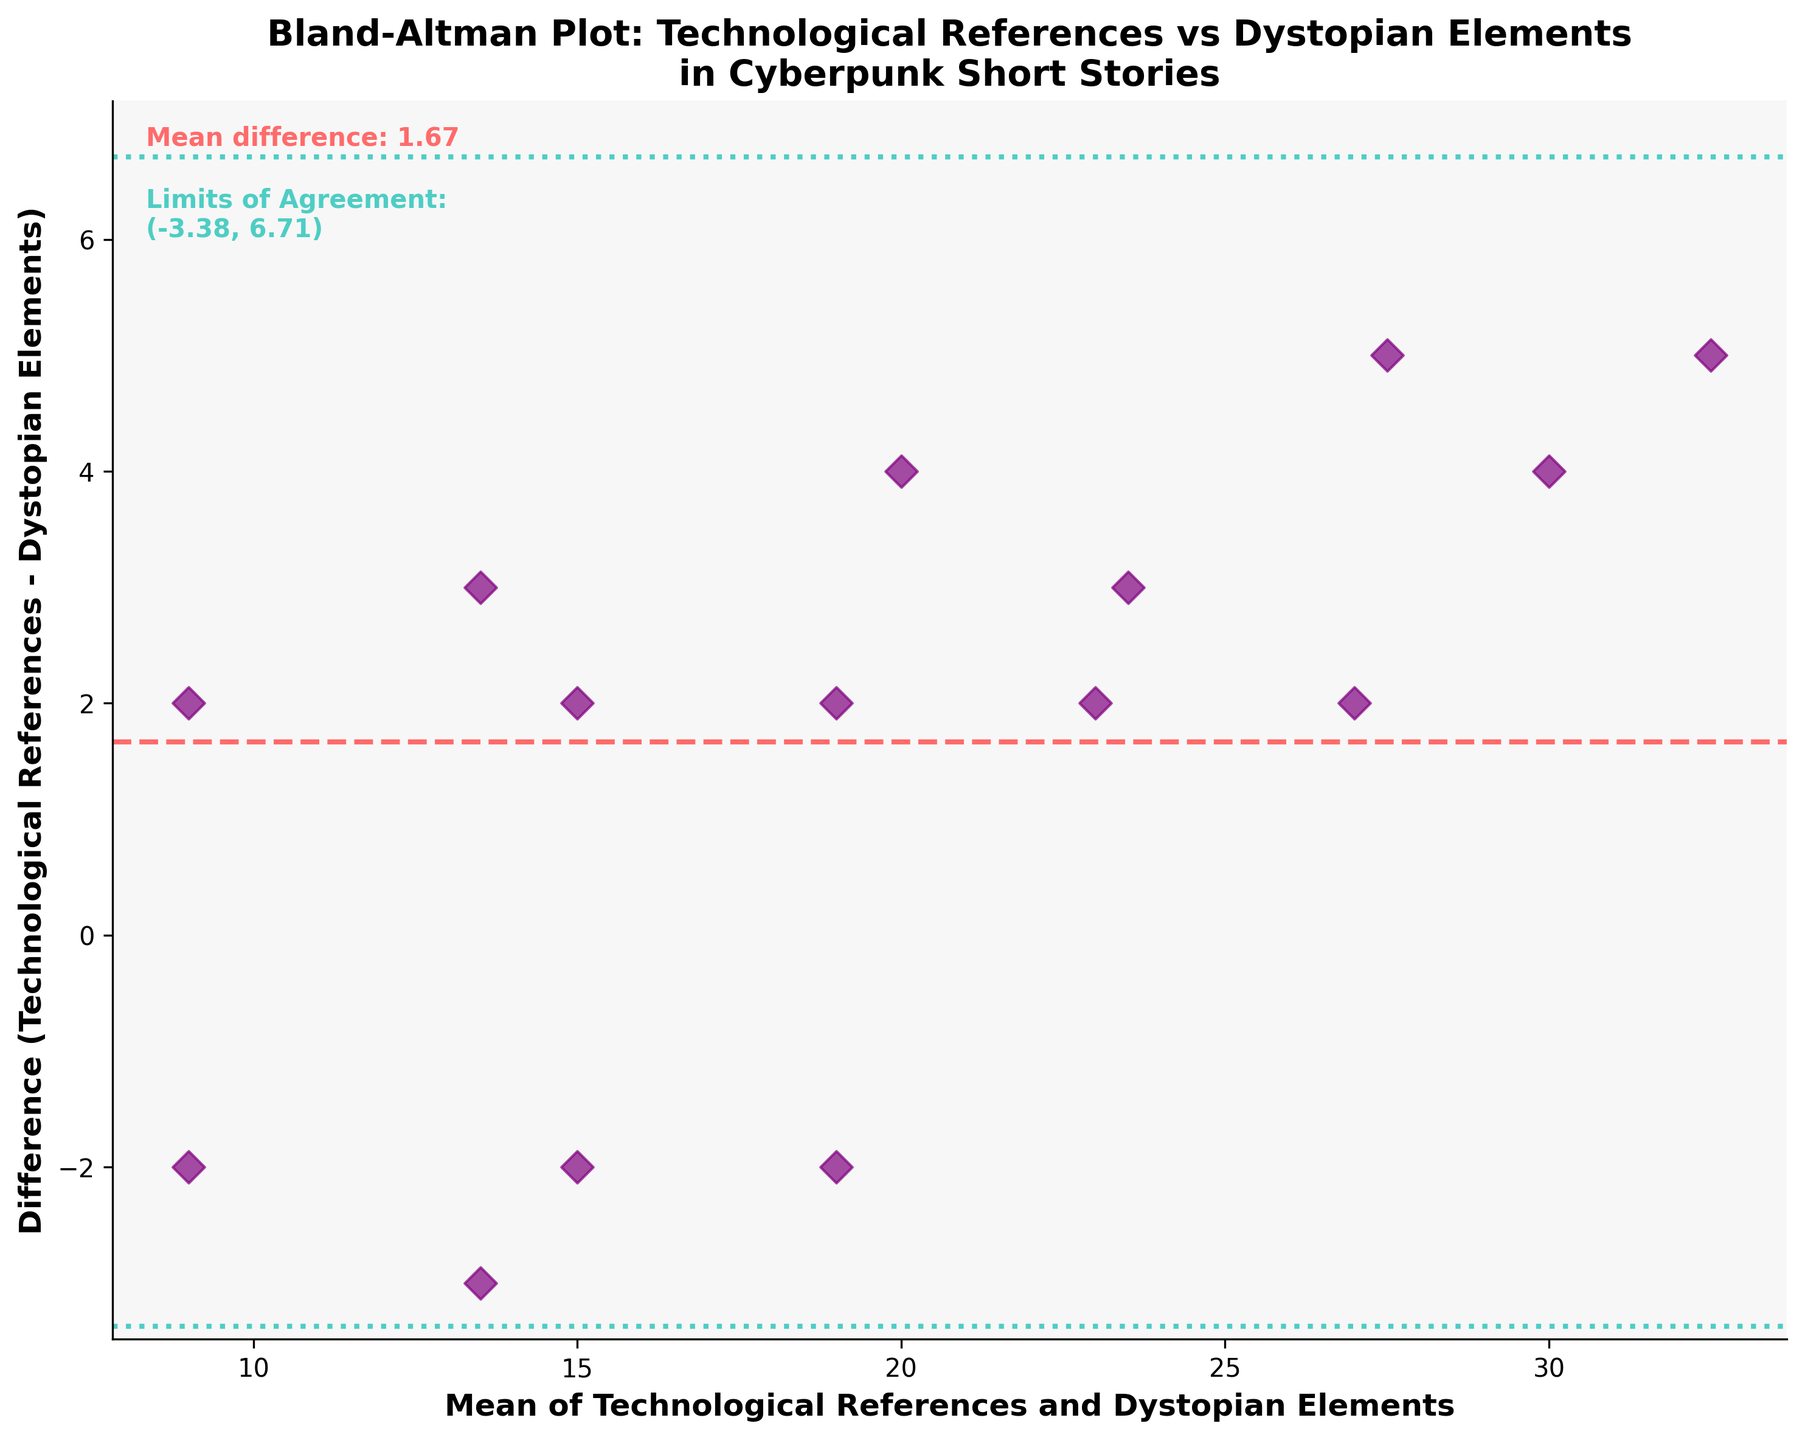What is the title of the plot? The title of the plot is written at the top center of the figure. It reads "Bland-Altman Plot: Technological References vs Dystopian Elements in Cyberpunk Short Stories".
Answer: Bland-Altman Plot: Technological References vs Dystopian Elements in Cyberpunk Short Stories What does the x-axis represent? The x-axis is labeled, and it represents the "Mean of Technological References and Dystopian Elements".
Answer: Mean of Technological References and Dystopian Elements What color are the points on the plot? The points on the plot are purple.
Answer: Purple How many data points are plotted on the figure? By counting each individual point on the plot, one can determine that there are 15 data points.
Answer: 15 What is the mean difference in the plot? The mean difference is annotated on the plot, inside the figure area; it reads "Mean difference: 1.60".
Answer: 1.60 What are the Limits of Agreement shown in the plot? The limits of agreement are annotated on the plot, inside the figure area. They read as "Limits of Agreement: (-2.18, 5.38)".
Answer: (-2.18, 5.38) Which data point has the highest mean value and what is its difference? By locating the highest point along the x-axis, we see that the mean value is 32.5, and its corresponding difference, as viewed from the plot, is 5.
Answer: 32.5, 5 How many data points fall outside the Limits of Agreement? To answer, one needs to count the number of points that lie above 5.38 or below -2.18 as marked by the horizontal lines. There are no data points outside these limits.
Answer: 0 Which range does the majority of the differences lie within on the figure? The majority of differences lie within the two green dotted lines representing the Limits of Agreement (-2.18 to 5.38). By visual inspection, most of the points fall between these lines.
Answer: -2.18 to 5.38 